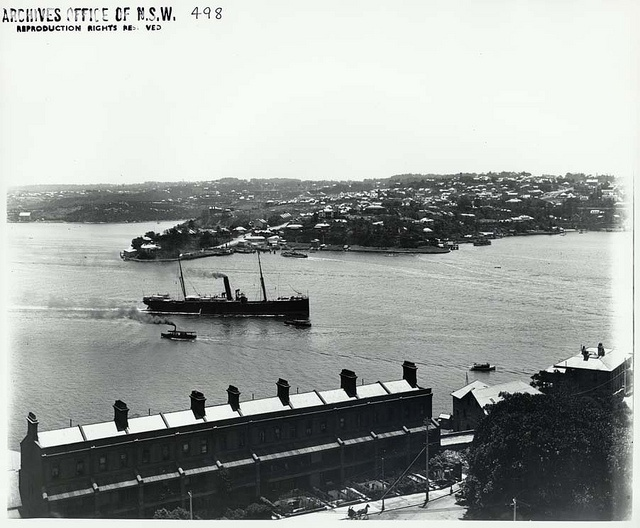Describe the objects in this image and their specific colors. I can see boat in white, black, darkgray, gray, and lightgray tones, boat in white, black, and gray tones, boat in white, black, gray, and darkgray tones, boat in ivory, black, gray, and darkgray tones, and boat in white, black, gray, and darkgray tones in this image. 